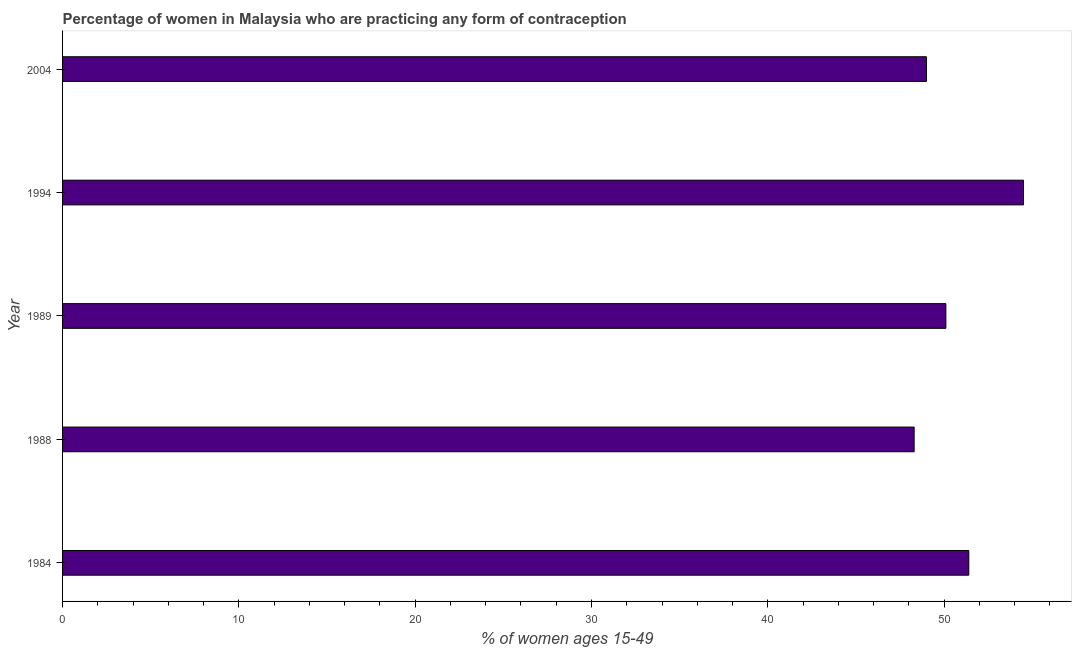What is the title of the graph?
Your response must be concise. Percentage of women in Malaysia who are practicing any form of contraception. What is the label or title of the X-axis?
Your answer should be compact. % of women ages 15-49. What is the contraceptive prevalence in 1994?
Your answer should be very brief. 54.5. Across all years, what is the maximum contraceptive prevalence?
Make the answer very short. 54.5. Across all years, what is the minimum contraceptive prevalence?
Your answer should be very brief. 48.3. In which year was the contraceptive prevalence minimum?
Offer a terse response. 1988. What is the sum of the contraceptive prevalence?
Make the answer very short. 253.3. What is the average contraceptive prevalence per year?
Provide a short and direct response. 50.66. What is the median contraceptive prevalence?
Your answer should be compact. 50.1. In how many years, is the contraceptive prevalence greater than 2 %?
Make the answer very short. 5. What is the ratio of the contraceptive prevalence in 1994 to that in 2004?
Keep it short and to the point. 1.11. Is the contraceptive prevalence in 1988 less than that in 1994?
Provide a short and direct response. Yes. What is the difference between the highest and the lowest contraceptive prevalence?
Provide a succinct answer. 6.2. What is the difference between two consecutive major ticks on the X-axis?
Make the answer very short. 10. Are the values on the major ticks of X-axis written in scientific E-notation?
Ensure brevity in your answer.  No. What is the % of women ages 15-49 in 1984?
Your answer should be very brief. 51.4. What is the % of women ages 15-49 in 1988?
Ensure brevity in your answer.  48.3. What is the % of women ages 15-49 in 1989?
Keep it short and to the point. 50.1. What is the % of women ages 15-49 in 1994?
Keep it short and to the point. 54.5. What is the % of women ages 15-49 in 2004?
Provide a short and direct response. 49. What is the difference between the % of women ages 15-49 in 1984 and 1994?
Your response must be concise. -3.1. What is the difference between the % of women ages 15-49 in 1988 and 1989?
Make the answer very short. -1.8. What is the difference between the % of women ages 15-49 in 1988 and 1994?
Make the answer very short. -6.2. What is the difference between the % of women ages 15-49 in 1989 and 1994?
Offer a very short reply. -4.4. What is the difference between the % of women ages 15-49 in 1989 and 2004?
Your response must be concise. 1.1. What is the difference between the % of women ages 15-49 in 1994 and 2004?
Your response must be concise. 5.5. What is the ratio of the % of women ages 15-49 in 1984 to that in 1988?
Ensure brevity in your answer.  1.06. What is the ratio of the % of women ages 15-49 in 1984 to that in 1989?
Make the answer very short. 1.03. What is the ratio of the % of women ages 15-49 in 1984 to that in 1994?
Your answer should be very brief. 0.94. What is the ratio of the % of women ages 15-49 in 1984 to that in 2004?
Ensure brevity in your answer.  1.05. What is the ratio of the % of women ages 15-49 in 1988 to that in 1994?
Provide a succinct answer. 0.89. What is the ratio of the % of women ages 15-49 in 1989 to that in 1994?
Your answer should be very brief. 0.92. What is the ratio of the % of women ages 15-49 in 1989 to that in 2004?
Give a very brief answer. 1.02. What is the ratio of the % of women ages 15-49 in 1994 to that in 2004?
Provide a succinct answer. 1.11. 